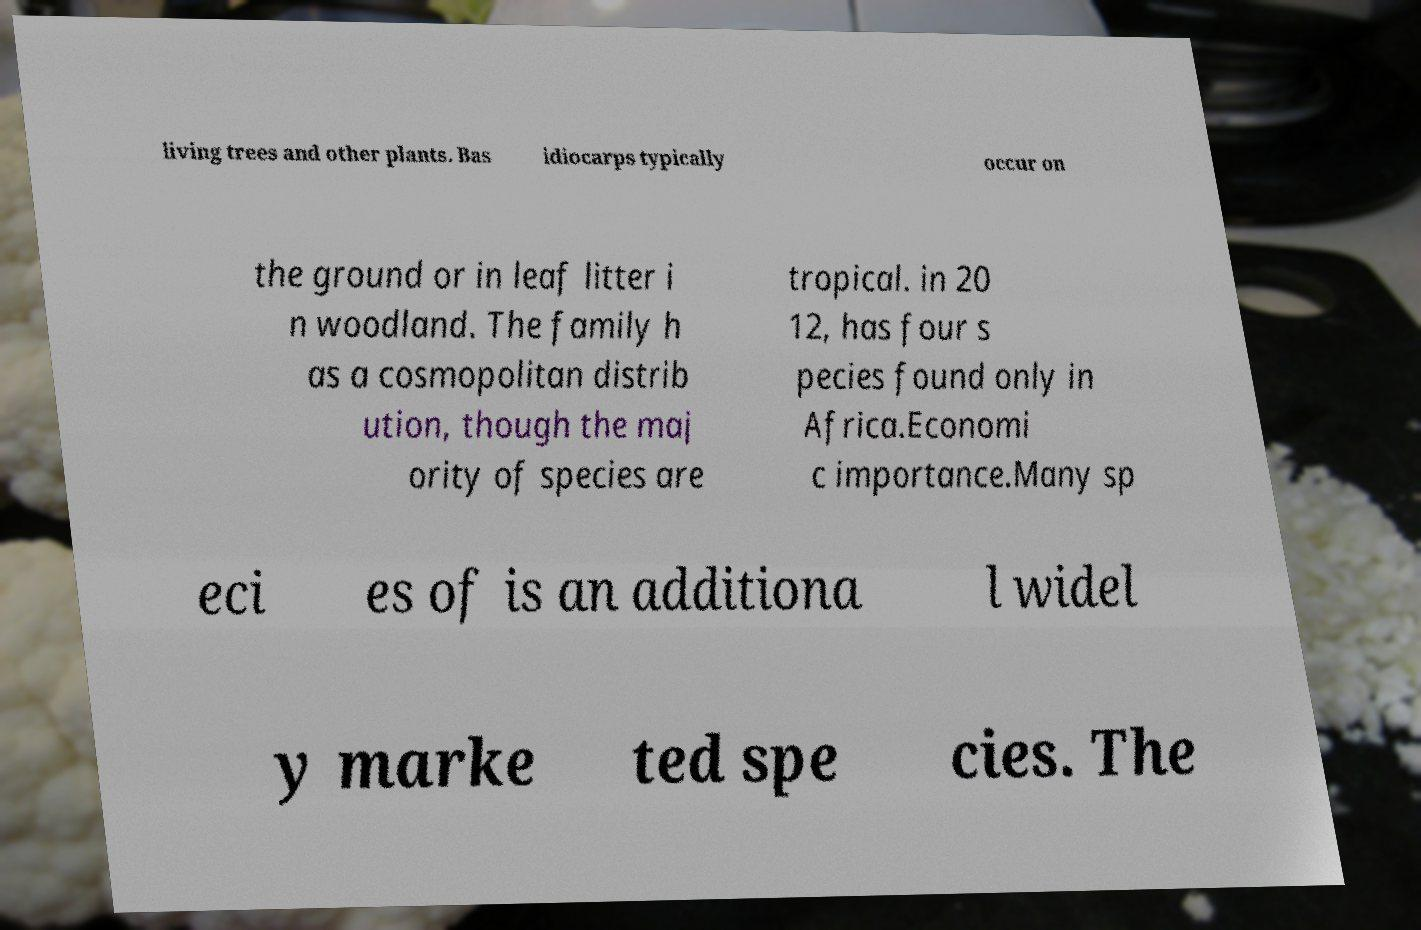Please identify and transcribe the text found in this image. living trees and other plants. Bas idiocarps typically occur on the ground or in leaf litter i n woodland. The family h as a cosmopolitan distrib ution, though the maj ority of species are tropical. in 20 12, has four s pecies found only in Africa.Economi c importance.Many sp eci es of is an additiona l widel y marke ted spe cies. The 